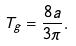<formula> <loc_0><loc_0><loc_500><loc_500>T _ { g } = \frac { 8 a } { 3 \pi } .</formula> 